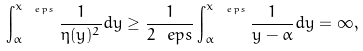Convert formula to latex. <formula><loc_0><loc_0><loc_500><loc_500>\int _ { \alpha } ^ { x _ { \ e p s } } \frac { 1 } { \eta ( y ) ^ { 2 } } d y \geq \frac { 1 } { 2 \ e p s } \int _ { \alpha } ^ { x _ { \ e p s } } \frac { 1 } { y - \alpha } d y = \infty ,</formula> 